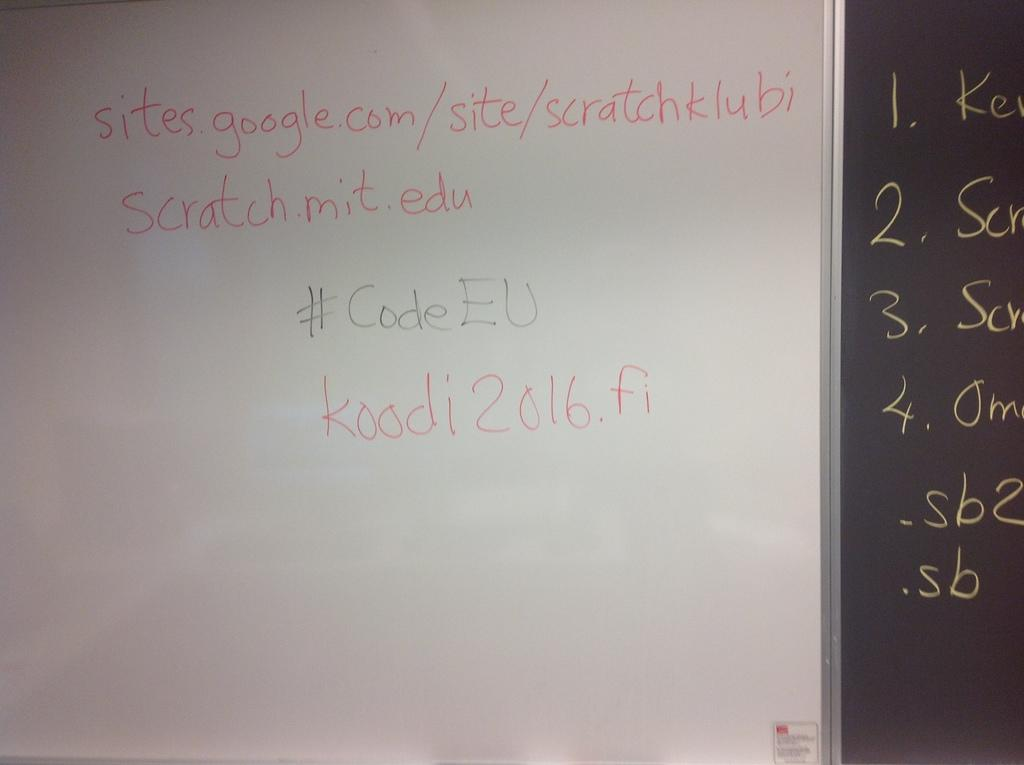<image>
Present a compact description of the photo's key features. a piece of code about a google site with its login code. 